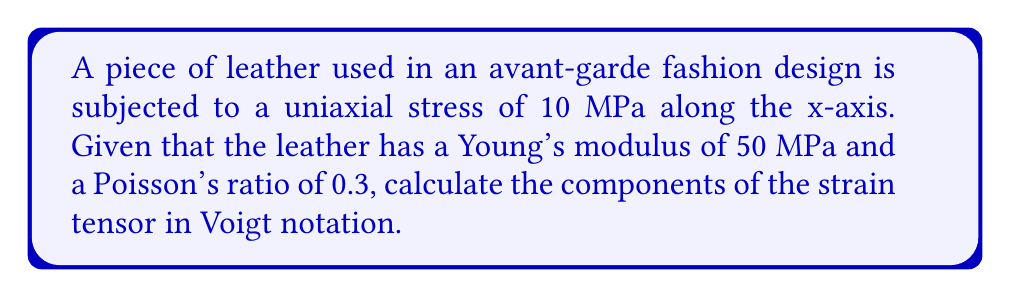Show me your answer to this math problem. Let's approach this step-by-step:

1) In a uniaxial stress state, the stress tensor in Voigt notation is:
   $$\sigma = [10, 0, 0, 0, 0, 0]^T \text{ MPa}$$

2) For linear elastic materials, we use Hooke's law:
   $$\epsilon = S \sigma$$
   where $\epsilon$ is the strain tensor, $\sigma$ is the stress tensor, and $S$ is the compliance matrix.

3) For an isotropic material, the compliance matrix is:
   $$S = \frac{1}{E}
   \begin{bmatrix}
   1 & -\nu & -\nu & 0 & 0 & 0 \\
   -\nu & 1 & -\nu & 0 & 0 & 0 \\
   -\nu & -\nu & 1 & 0 & 0 & 0 \\
   0 & 0 & 0 & 2(1+\nu) & 0 & 0 \\
   0 & 0 & 0 & 0 & 2(1+\nu) & 0 \\
   0 & 0 & 0 & 0 & 0 & 2(1+\nu)
   \end{bmatrix}$$
   where $E$ is Young's modulus and $\nu$ is Poisson's ratio.

4) Substituting the given values:
   $$S = \frac{1}{50}
   \begin{bmatrix}
   1 & -0.3 & -0.3 & 0 & 0 & 0 \\
   -0.3 & 1 & -0.3 & 0 & 0 & 0 \\
   -0.3 & -0.3 & 1 & 0 & 0 & 0 \\
   0 & 0 & 0 & 2.6 & 0 & 0 \\
   0 & 0 & 0 & 0 & 2.6 & 0 \\
   0 & 0 & 0 & 0 & 0 & 2.6
   \end{bmatrix}$$

5) Now we can calculate the strain tensor:
   $$\epsilon = S \sigma = \frac{1}{50}
   \begin{bmatrix}
   1 & -0.3 & -0.3 & 0 & 0 & 0 \\
   -0.3 & 1 & -0.3 & 0 & 0 & 0 \\
   -0.3 & -0.3 & 1 & 0 & 0 & 0 \\
   0 & 0 & 0 & 2.6 & 0 & 0 \\
   0 & 0 & 0 & 0 & 2.6 & 0 \\
   0 & 0 & 0 & 0 & 0 & 2.6
   \end{bmatrix}
   \begin{bmatrix}
   10 \\ 0 \\ 0 \\ 0 \\ 0 \\ 0
   \end{bmatrix}$$

6) Performing the matrix multiplication:
   $$\epsilon = \frac{1}{50}
   \begin{bmatrix}
   10 \\ -3 \\ -3 \\ 0 \\ 0 \\ 0
   \end{bmatrix} =
   \begin{bmatrix}
   0.2 \\ -0.06 \\ -0.06 \\ 0 \\ 0 \\ 0
   \end{bmatrix}$$

Therefore, the components of the strain tensor in Voigt notation are [0.2, -0.06, -0.06, 0, 0, 0].
Answer: [0.2, -0.06, -0.06, 0, 0, 0] 